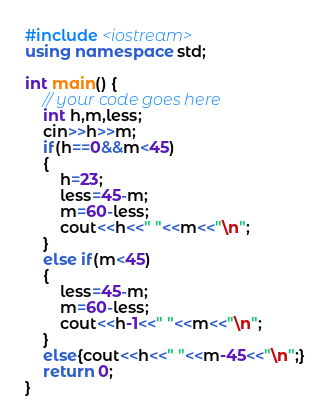<code> <loc_0><loc_0><loc_500><loc_500><_C++_>#include <iostream>
using namespace std;

int main() {
    // your code goes here
    int h,m,less;
    cin>>h>>m;
    if(h==0&&m<45)
    {
        h=23;
        less=45-m;
        m=60-less;
        cout<<h<<" "<<m<<"\n";
    }
    else if(m<45)
    {
        less=45-m;
        m=60-less;
        cout<<h-1<<" "<<m<<"\n";
    }
    else{cout<<h<<" "<<m-45<<"\n";}
    return 0;
}
</code> 